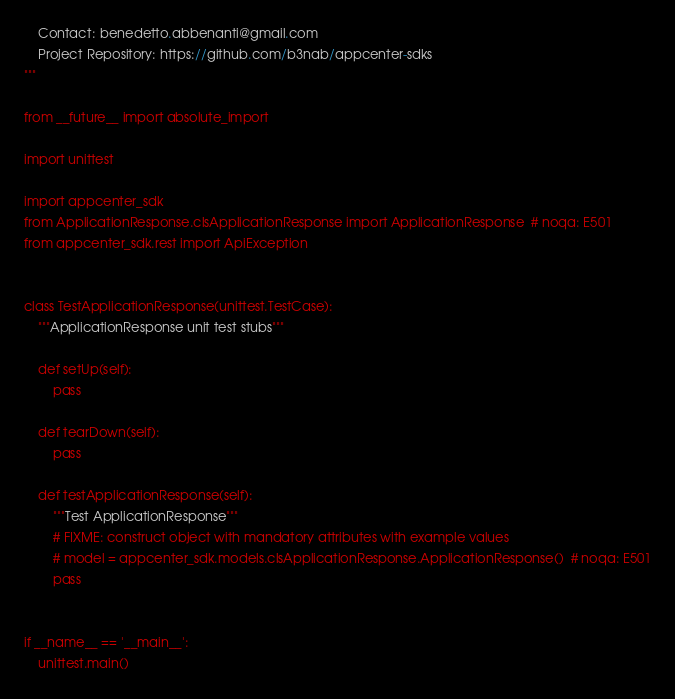<code> <loc_0><loc_0><loc_500><loc_500><_Python_>    Contact: benedetto.abbenanti@gmail.com
    Project Repository: https://github.com/b3nab/appcenter-sdks
"""

from __future__ import absolute_import

import unittest

import appcenter_sdk
from ApplicationResponse.clsApplicationResponse import ApplicationResponse  # noqa: E501
from appcenter_sdk.rest import ApiException


class TestApplicationResponse(unittest.TestCase):
    """ApplicationResponse unit test stubs"""

    def setUp(self):
        pass

    def tearDown(self):
        pass

    def testApplicationResponse(self):
        """Test ApplicationResponse"""
        # FIXME: construct object with mandatory attributes with example values
        # model = appcenter_sdk.models.clsApplicationResponse.ApplicationResponse()  # noqa: E501
        pass


if __name__ == '__main__':
    unittest.main()
</code> 